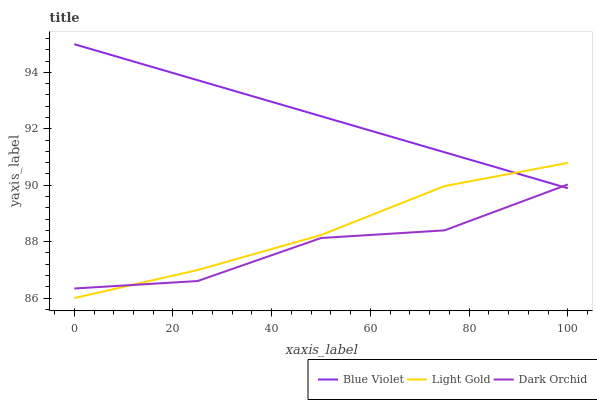Does Dark Orchid have the minimum area under the curve?
Answer yes or no. Yes. Does Blue Violet have the maximum area under the curve?
Answer yes or no. Yes. Does Blue Violet have the minimum area under the curve?
Answer yes or no. No. Does Dark Orchid have the maximum area under the curve?
Answer yes or no. No. Is Blue Violet the smoothest?
Answer yes or no. Yes. Is Dark Orchid the roughest?
Answer yes or no. Yes. Is Dark Orchid the smoothest?
Answer yes or no. No. Is Blue Violet the roughest?
Answer yes or no. No. Does Light Gold have the lowest value?
Answer yes or no. Yes. Does Dark Orchid have the lowest value?
Answer yes or no. No. Does Blue Violet have the highest value?
Answer yes or no. Yes. Does Dark Orchid have the highest value?
Answer yes or no. No. Does Dark Orchid intersect Blue Violet?
Answer yes or no. Yes. Is Dark Orchid less than Blue Violet?
Answer yes or no. No. Is Dark Orchid greater than Blue Violet?
Answer yes or no. No. 